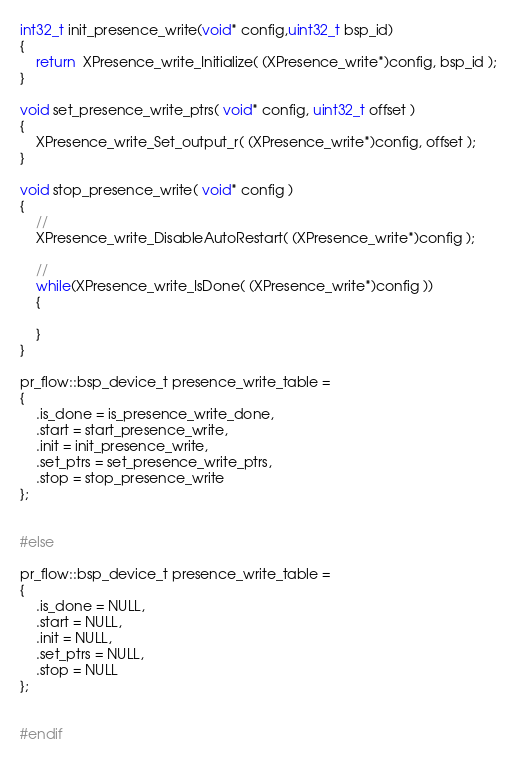<code> <loc_0><loc_0><loc_500><loc_500><_C_>
int32_t init_presence_write(void* config,uint32_t bsp_id)
{
    return  XPresence_write_Initialize( (XPresence_write*)config, bsp_id );
}

void set_presence_write_ptrs( void* config, uint32_t offset )
{
    XPresence_write_Set_output_r( (XPresence_write*)config, offset );
}

void stop_presence_write( void* config )
{
    //
    XPresence_write_DisableAutoRestart( (XPresence_write*)config );

    //
    while(XPresence_write_IsDone( (XPresence_write*)config ))
    {

    }
}

pr_flow::bsp_device_t presence_write_table =
{
    .is_done = is_presence_write_done,
    .start = start_presence_write,
    .init = init_presence_write,
    .set_ptrs = set_presence_write_ptrs,
    .stop = stop_presence_write
};


#else

pr_flow::bsp_device_t presence_write_table =
{
    .is_done = NULL,
    .start = NULL,
    .init = NULL,
    .set_ptrs = NULL,
    .stop = NULL
};


#endif

</code> 